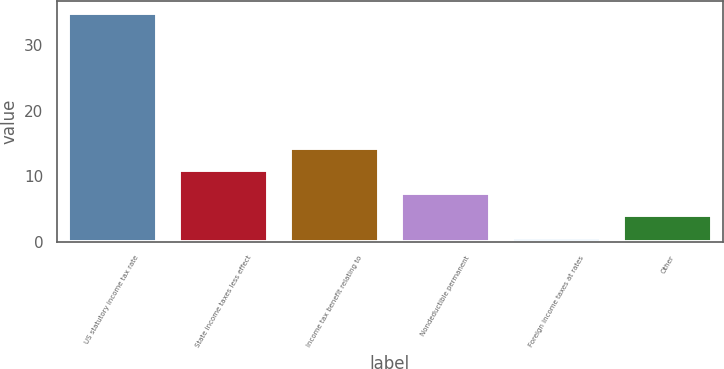Convert chart to OTSL. <chart><loc_0><loc_0><loc_500><loc_500><bar_chart><fcel>US statutory income tax rate<fcel>State income taxes less effect<fcel>Income tax benefit relating to<fcel>Nondeductible permanent<fcel>Foreign income taxes at rates<fcel>Other<nl><fcel>35<fcel>10.92<fcel>14.36<fcel>7.48<fcel>0.6<fcel>4.04<nl></chart> 